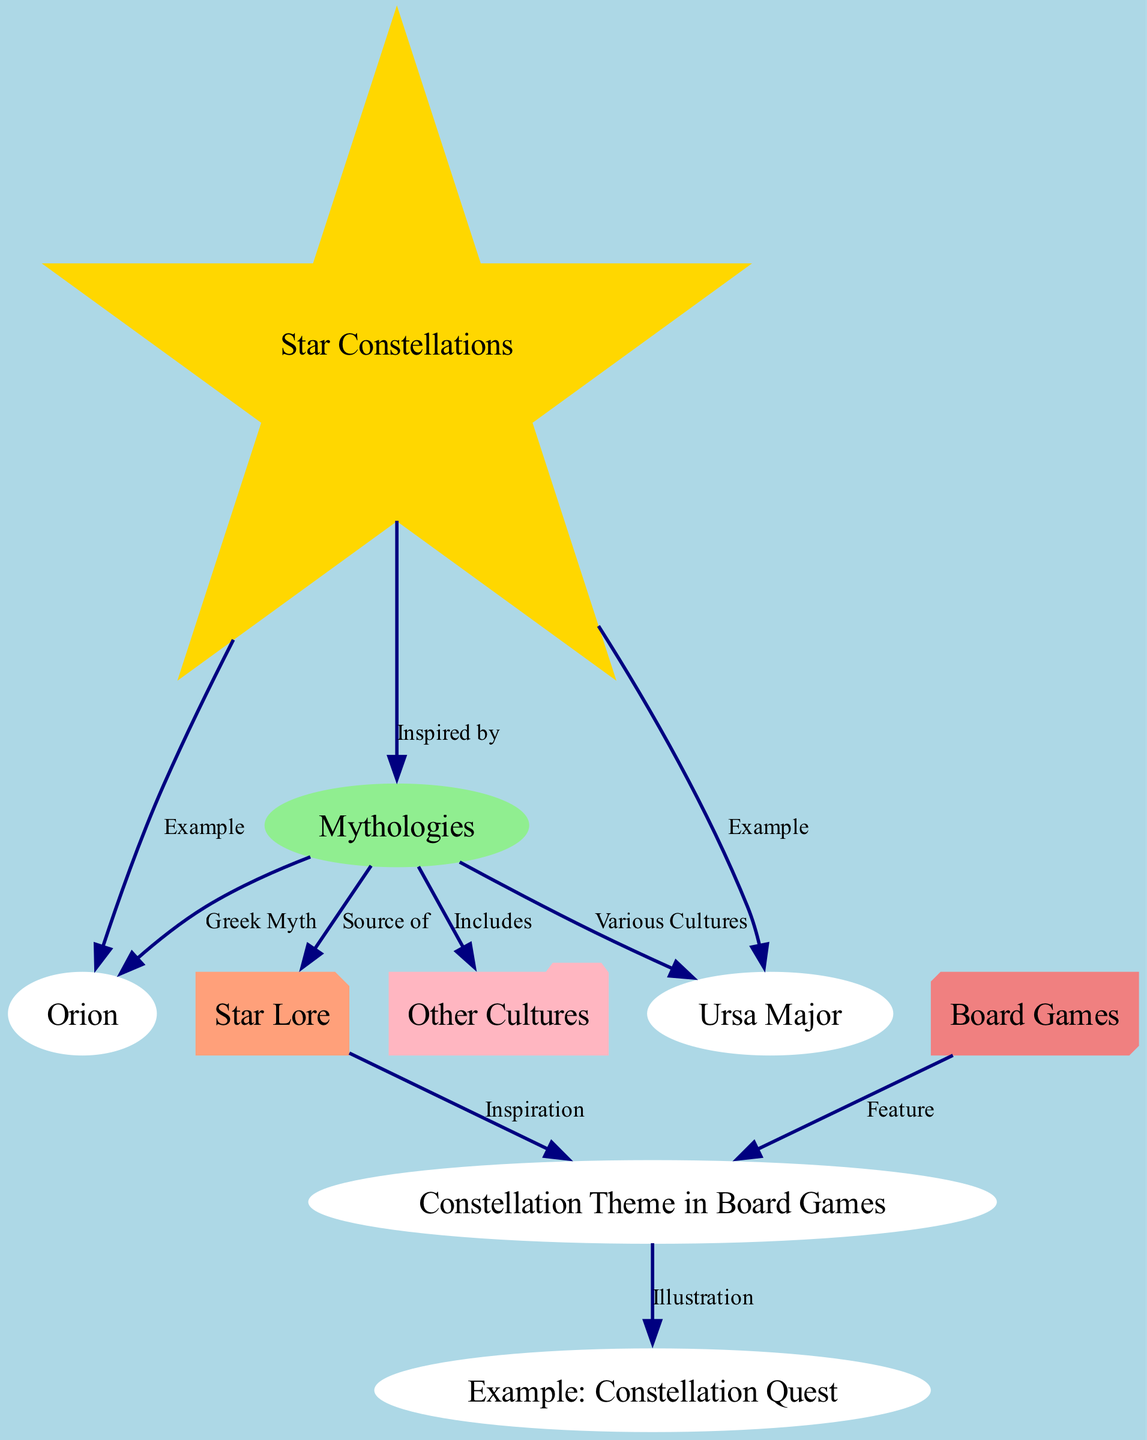What are the two examples of constellations listed? The diagram specifically names Orion and Ursa Major as examples of star constellations under the "constellations" node.
Answer: Orion, Ursa Major How many nodes are present in the diagram? The diagram features a total of 9 nodes, including constellations, mythologies, games, and others.
Answer: 9 What is the relationship between constellations and mythologies? The diagram indicates that constellations are inspired by various mythologies, highlighting their interconnectedness.
Answer: Inspired by What is the source of star lore according to the diagram? The diagram states that star lore is derived from mythologies, connecting these traditional stories to their origins.
Answer: Mythologies Which constellation is associated with Greek myth? The diagram directly links Orion to Greek myth, establishing this connection clearly.
Answer: Orion How does the diagram illustrate the theme of constellations in board games? The relationship shows that board games feature constellation themes, exemplified by "Constellation Quest," which highlights this thematic element.
Answer: Feature What cultures are included in the mythologies node? The "mythologies" node includes "other cultures," which suggests a broader range of mythological stories beyond a single tradition.
Answer: Other Cultures Which node illustrates an example of a board game? "Constellation Example" is the specific node that illustrates an example of a board game connected to constellation themes.
Answer: Example: Constellation Quest What does the arrow labeled "Illustration" represent in the context of the diagram? The "Illustration" label shows how the "constellationTheme" connects to the specific example of a board game, indicating that the theme manifests in a game design.
Answer: Illustration 